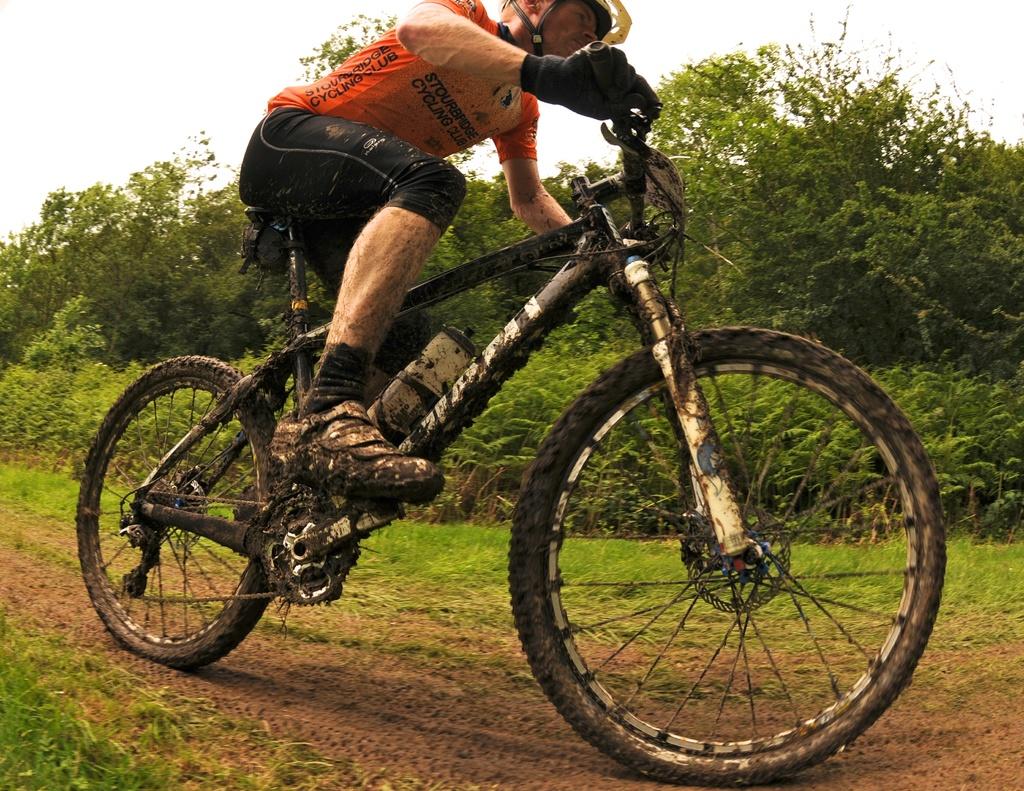Is he rising a book?
Your response must be concise. Unanswerable. 